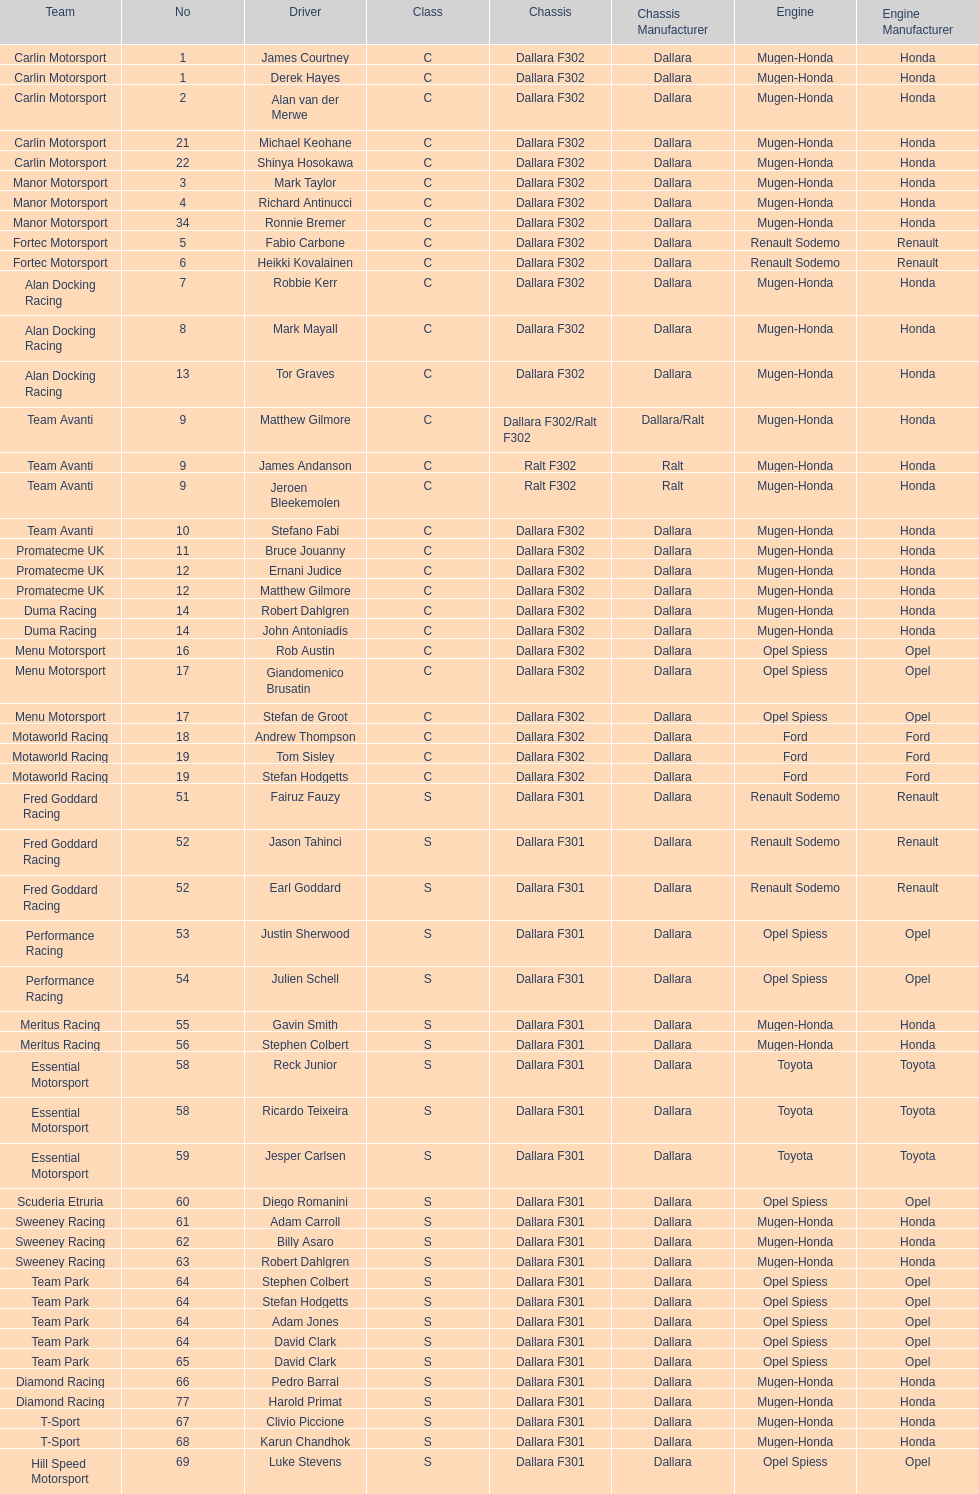Which power source was used the most by teams this season? Mugen-Honda. 